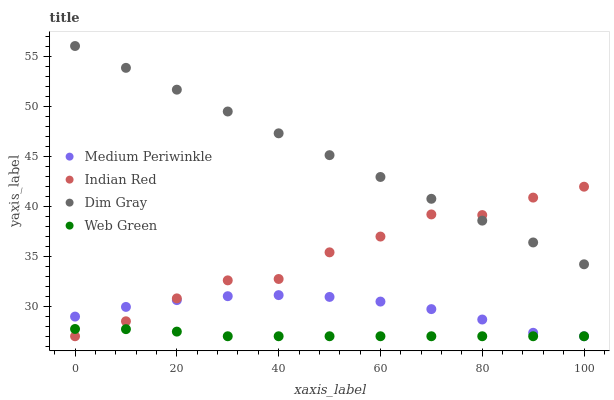Does Web Green have the minimum area under the curve?
Answer yes or no. Yes. Does Dim Gray have the maximum area under the curve?
Answer yes or no. Yes. Does Medium Periwinkle have the minimum area under the curve?
Answer yes or no. No. Does Medium Periwinkle have the maximum area under the curve?
Answer yes or no. No. Is Dim Gray the smoothest?
Answer yes or no. Yes. Is Indian Red the roughest?
Answer yes or no. Yes. Is Medium Periwinkle the smoothest?
Answer yes or no. No. Is Medium Periwinkle the roughest?
Answer yes or no. No. Does Medium Periwinkle have the lowest value?
Answer yes or no. Yes. Does Dim Gray have the highest value?
Answer yes or no. Yes. Does Medium Periwinkle have the highest value?
Answer yes or no. No. Is Medium Periwinkle less than Dim Gray?
Answer yes or no. Yes. Is Dim Gray greater than Medium Periwinkle?
Answer yes or no. Yes. Does Indian Red intersect Medium Periwinkle?
Answer yes or no. Yes. Is Indian Red less than Medium Periwinkle?
Answer yes or no. No. Is Indian Red greater than Medium Periwinkle?
Answer yes or no. No. Does Medium Periwinkle intersect Dim Gray?
Answer yes or no. No. 